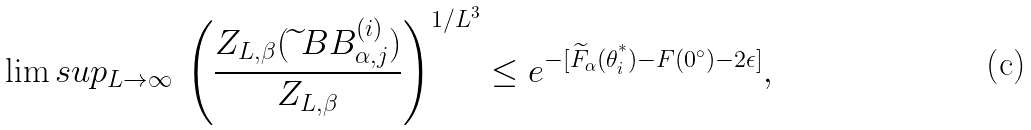Convert formula to latex. <formula><loc_0><loc_0><loc_500><loc_500>\lim s u p _ { L \to \infty } \, \left ( \frac { Z _ { L , \beta } ( \widetilde { \ } B B _ { \alpha , j } ^ { ( i ) } ) } { Z _ { L , \beta } } \right ) ^ { 1 / L ^ { 3 } } \leq e ^ { - [ \widetilde { F } _ { \alpha } ( \theta _ { i } ^ { ^ { * } } ) - F ( 0 ^ { \circ } ) - 2 \epsilon ] } ,</formula> 